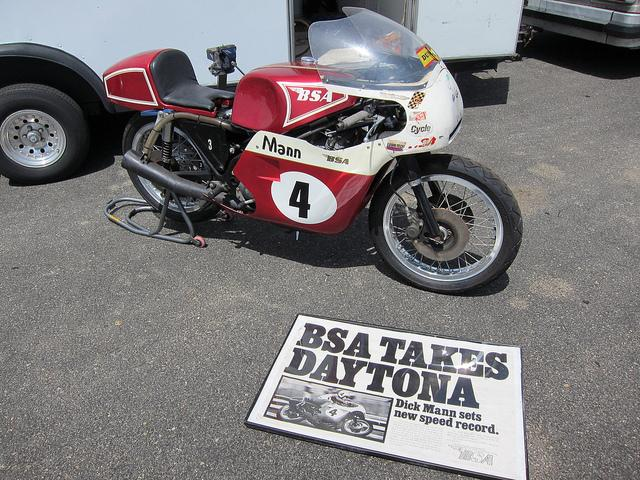What is the first name of the person who rode this bike? dick mann 